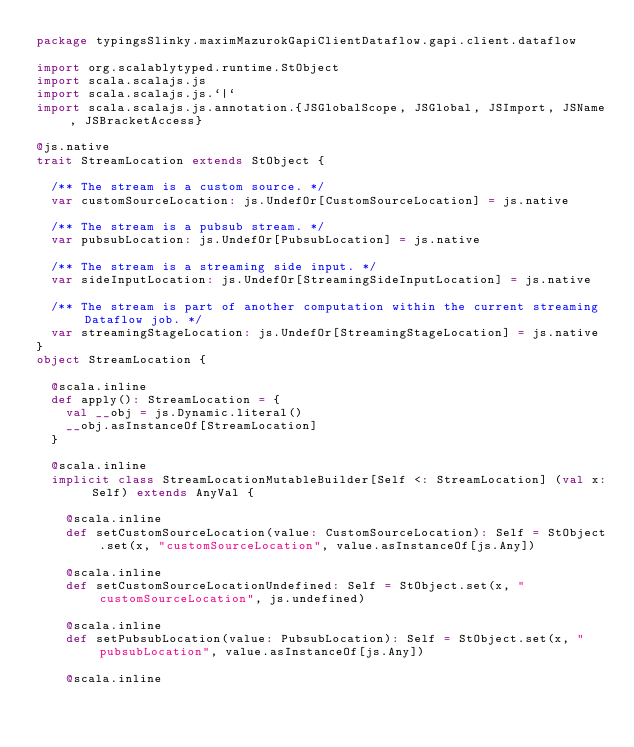<code> <loc_0><loc_0><loc_500><loc_500><_Scala_>package typingsSlinky.maximMazurokGapiClientDataflow.gapi.client.dataflow

import org.scalablytyped.runtime.StObject
import scala.scalajs.js
import scala.scalajs.js.`|`
import scala.scalajs.js.annotation.{JSGlobalScope, JSGlobal, JSImport, JSName, JSBracketAccess}

@js.native
trait StreamLocation extends StObject {
  
  /** The stream is a custom source. */
  var customSourceLocation: js.UndefOr[CustomSourceLocation] = js.native
  
  /** The stream is a pubsub stream. */
  var pubsubLocation: js.UndefOr[PubsubLocation] = js.native
  
  /** The stream is a streaming side input. */
  var sideInputLocation: js.UndefOr[StreamingSideInputLocation] = js.native
  
  /** The stream is part of another computation within the current streaming Dataflow job. */
  var streamingStageLocation: js.UndefOr[StreamingStageLocation] = js.native
}
object StreamLocation {
  
  @scala.inline
  def apply(): StreamLocation = {
    val __obj = js.Dynamic.literal()
    __obj.asInstanceOf[StreamLocation]
  }
  
  @scala.inline
  implicit class StreamLocationMutableBuilder[Self <: StreamLocation] (val x: Self) extends AnyVal {
    
    @scala.inline
    def setCustomSourceLocation(value: CustomSourceLocation): Self = StObject.set(x, "customSourceLocation", value.asInstanceOf[js.Any])
    
    @scala.inline
    def setCustomSourceLocationUndefined: Self = StObject.set(x, "customSourceLocation", js.undefined)
    
    @scala.inline
    def setPubsubLocation(value: PubsubLocation): Self = StObject.set(x, "pubsubLocation", value.asInstanceOf[js.Any])
    
    @scala.inline</code> 